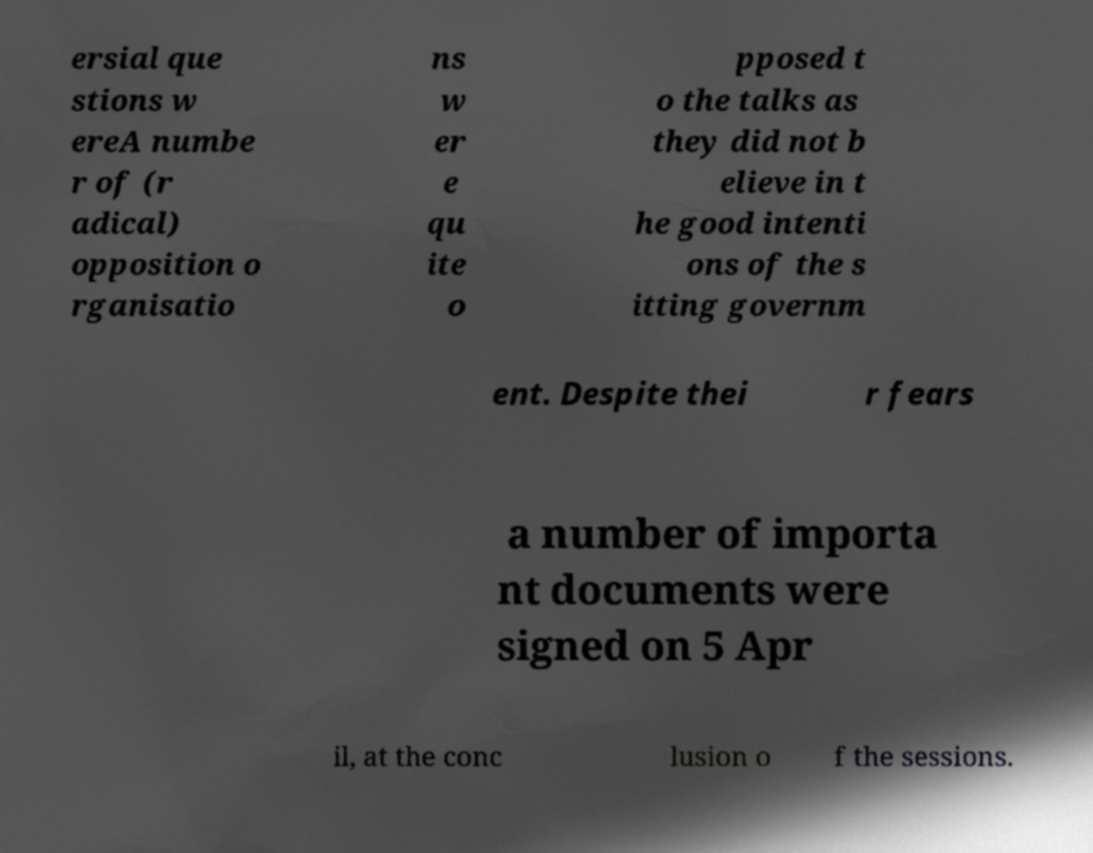Could you extract and type out the text from this image? ersial que stions w ereA numbe r of (r adical) opposition o rganisatio ns w er e qu ite o pposed t o the talks as they did not b elieve in t he good intenti ons of the s itting governm ent. Despite thei r fears a number of importa nt documents were signed on 5 Apr il, at the conc lusion o f the sessions. 